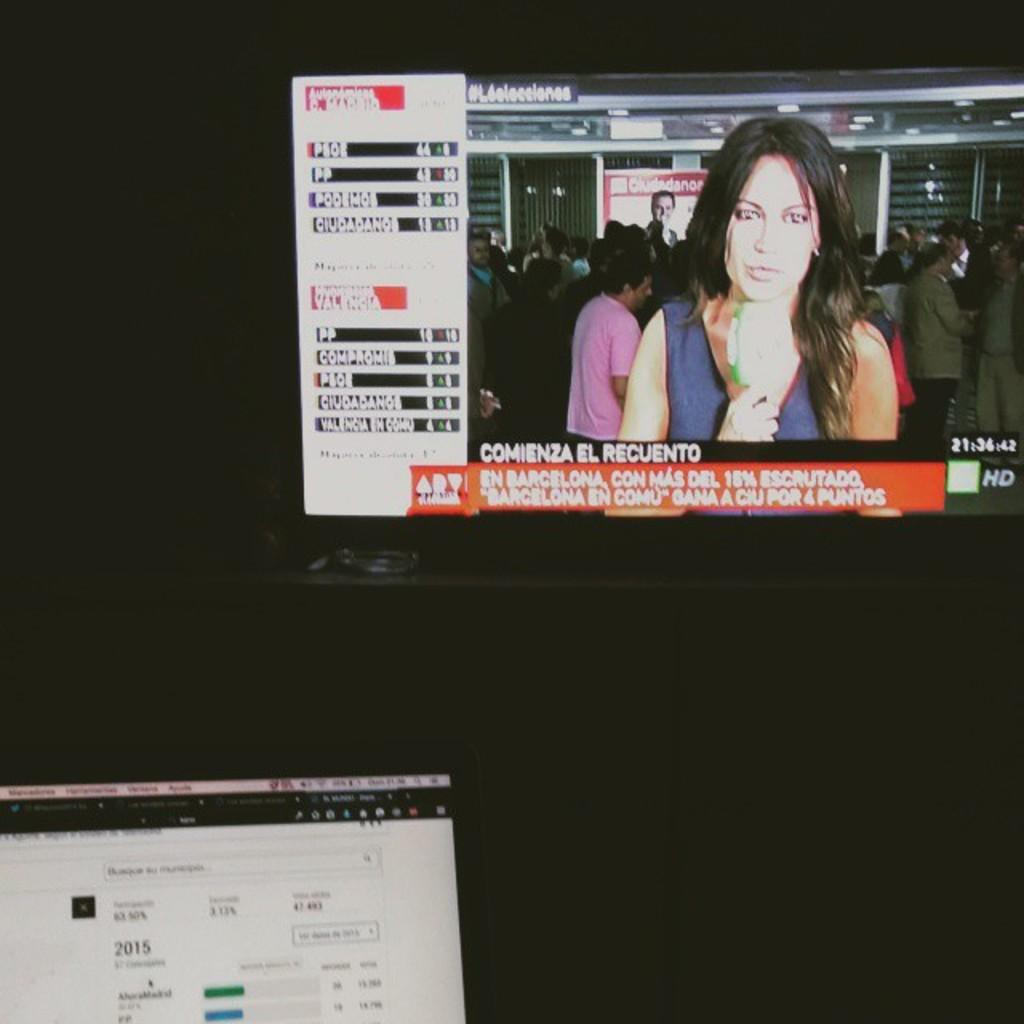How many screens are visible in the image? There are two screens in the image. What can be observed about the background of the image? The background is dark. What is happening on the right screen? There is a woman speaking on the right screen. What type of coal is being transported by the ship in the image? There is no ship or coal present in the image; it only features two screens and a woman speaking. 